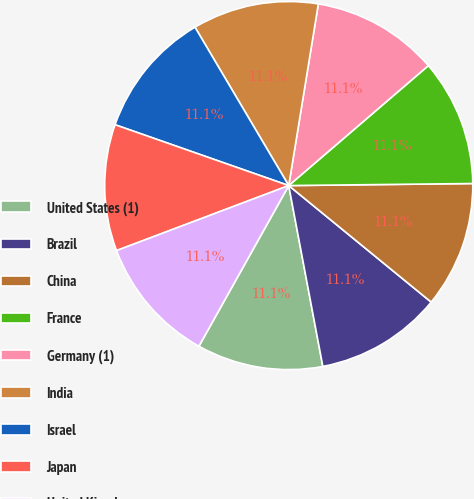Convert chart to OTSL. <chart><loc_0><loc_0><loc_500><loc_500><pie_chart><fcel>United States (1)<fcel>Brazil<fcel>China<fcel>France<fcel>Germany (1)<fcel>India<fcel>Israel<fcel>Japan<fcel>United Kingdom<nl><fcel>11.08%<fcel>11.12%<fcel>11.09%<fcel>11.12%<fcel>11.13%<fcel>11.08%<fcel>11.13%<fcel>11.11%<fcel>11.14%<nl></chart> 